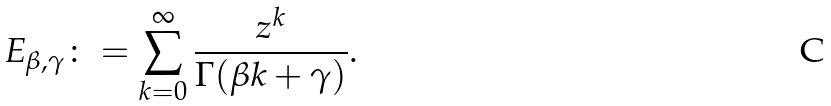<formula> <loc_0><loc_0><loc_500><loc_500>E _ { \beta , \gamma } \colon = \sum _ { k = 0 } ^ { \infty } \frac { z ^ { k } } { \Gamma ( \beta k + \gamma ) } .</formula> 